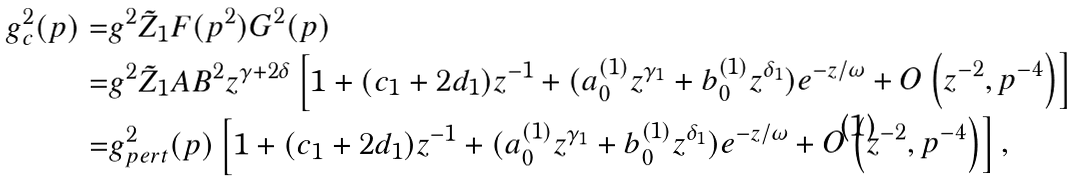Convert formula to latex. <formula><loc_0><loc_0><loc_500><loc_500>g ^ { 2 } _ { c } ( p ) = & g ^ { 2 } \tilde { Z } _ { 1 } F ( p ^ { 2 } ) G ^ { 2 } ( p ) \\ = & g ^ { 2 } \tilde { Z } _ { 1 } A B ^ { 2 } z ^ { \gamma + 2 \delta } \left [ 1 + ( c _ { 1 } + 2 d _ { 1 } ) z ^ { - 1 } + ( a _ { 0 } ^ { ( 1 ) } z ^ { \gamma _ { 1 } } + b _ { 0 } ^ { ( 1 ) } z ^ { \delta _ { 1 } } ) e ^ { - z / \omega } + O \left ( z ^ { - 2 } , p ^ { - 4 } \right ) \right ] \\ = & g ^ { 2 } _ { p e r t } ( p ) \left [ 1 + ( c _ { 1 } + 2 d _ { 1 } ) z ^ { - 1 } + ( a _ { 0 } ^ { ( 1 ) } z ^ { \gamma _ { 1 } } + b _ { 0 } ^ { ( 1 ) } z ^ { \delta _ { 1 } } ) e ^ { - z / \omega } + O \left ( z ^ { - 2 } , p ^ { - 4 } \right ) \right ] ,</formula> 